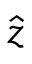<formula> <loc_0><loc_0><loc_500><loc_500>\hat { z }</formula> 